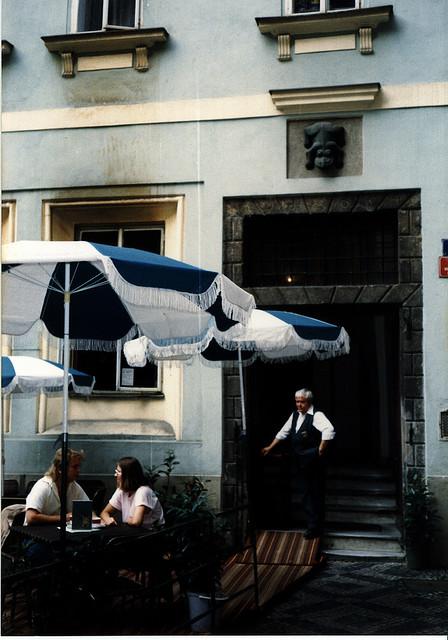Is it sunny?
Short answer required. Yes. What is providing shade?
Short answer required. Umbrella. Are these people seated outside?
Be succinct. Yes. 